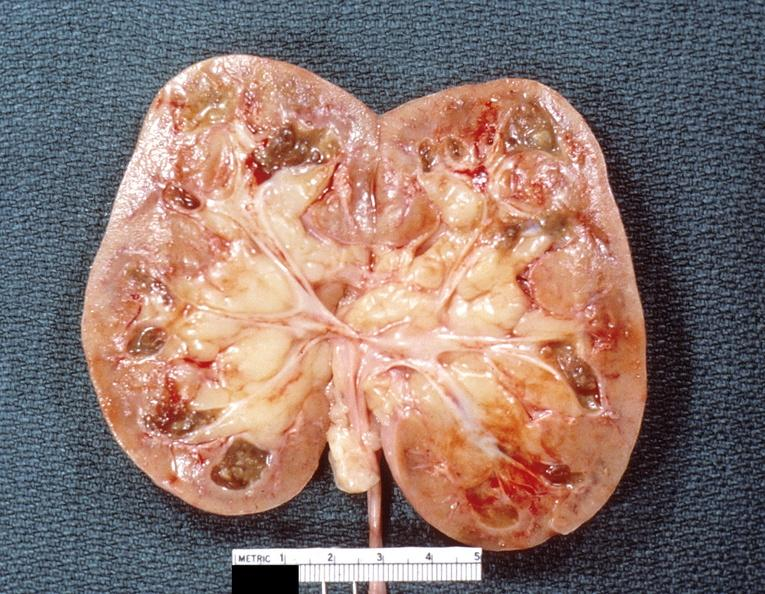does this image show kidney, renal papillary necrosis, subacute?
Answer the question using a single word or phrase. Yes 